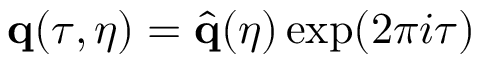Convert formula to latex. <formula><loc_0><loc_0><loc_500><loc_500>q ( \tau , \eta ) = \hat { q } ( { \eta } ) \exp ( 2 \pi i \tau )</formula> 